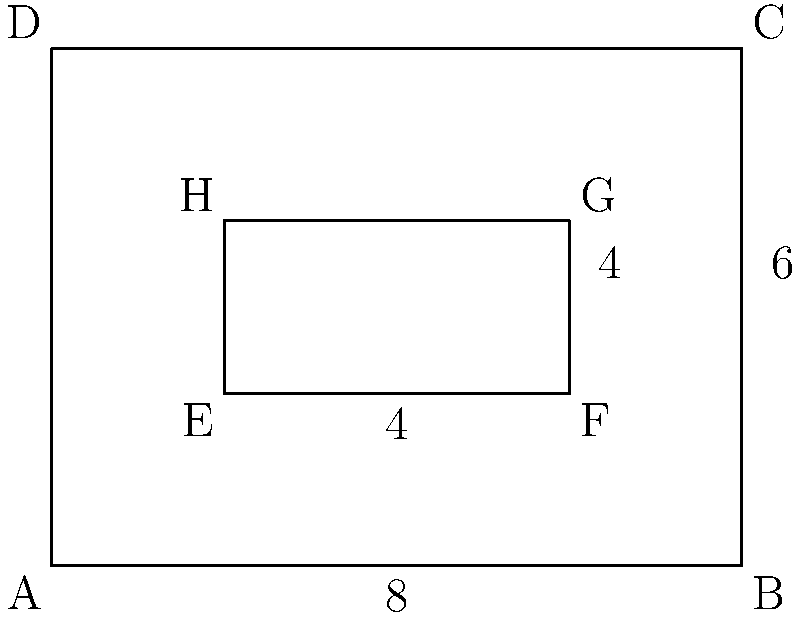A farmer wants to maximize the area of a rectangular field within a larger rectangular plot. The larger plot measures 8 units by 6 units. The farmer needs to leave a 2-unit wide buffer zone around the entire perimeter of the inner field for access and irrigation. What is the maximum area of the inner rectangular field that can be cultivated? To solve this problem, we'll follow these steps:

1) First, let's identify the dimensions of the inner rectangle:
   - The width of the inner rectangle = 8 - 2 - 2 = 4 units
   - The height of the inner rectangle = 6 - 2 - 2 = 2 units

2) The area of a rectangle is given by the formula:
   $$ A = l \times w $$
   where $A$ is the area, $l$ is the length, and $w$ is the width.

3) Substituting our values:
   $$ A = 4 \times 2 = 8 \text{ square units} $$

4) Therefore, the maximum area of the inner rectangular field is 8 square units.

This solution ensures that the 2-unit buffer zone is maintained around the entire perimeter of the inner field, maximizing the cultivable area within the given constraints.
Answer: 8 square units 